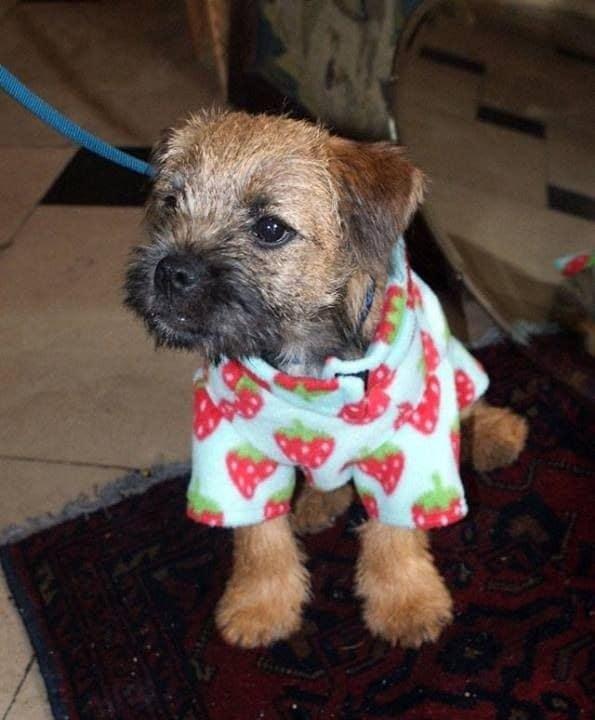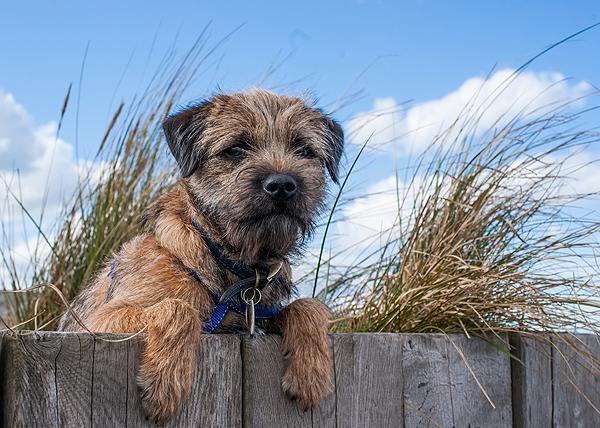The first image is the image on the left, the second image is the image on the right. For the images shown, is this caption "An image contains two dogs with their heads touching each other." true? Answer yes or no. No. 